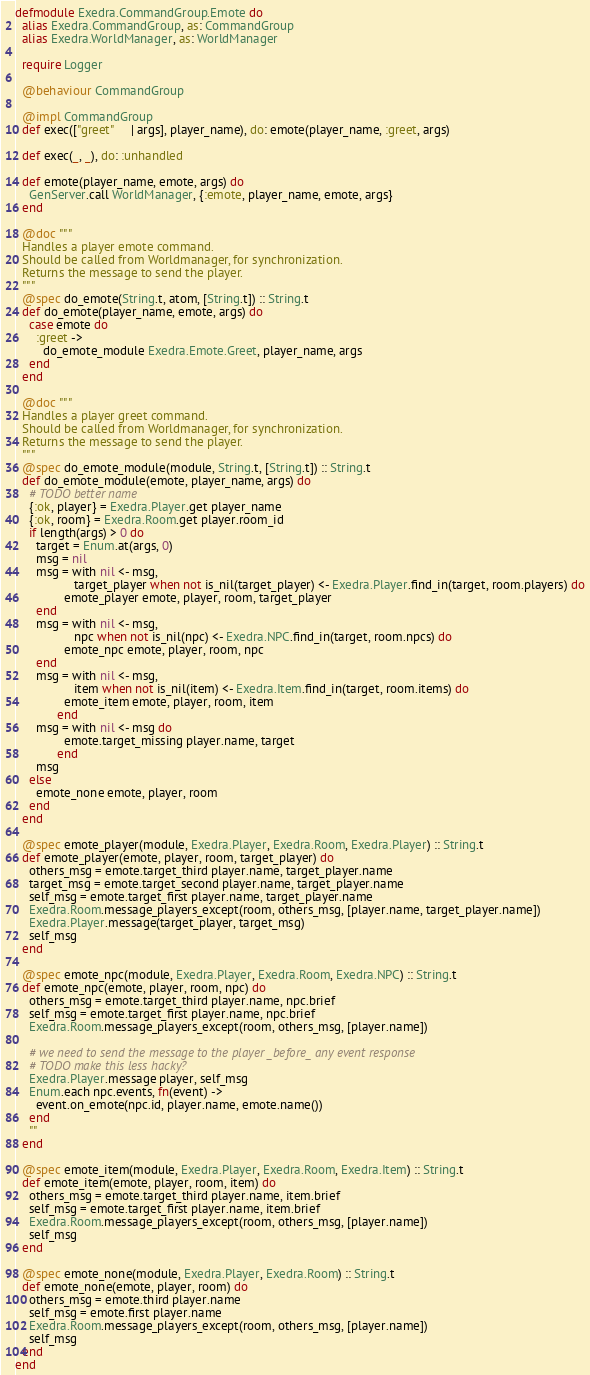Convert code to text. <code><loc_0><loc_0><loc_500><loc_500><_Elixir_>defmodule Exedra.CommandGroup.Emote do
  alias Exedra.CommandGroup, as: CommandGroup
  alias Exedra.WorldManager, as: WorldManager

  require Logger

  @behaviour CommandGroup

  @impl CommandGroup
  def exec(["greet"     | args], player_name), do: emote(player_name, :greet, args)

  def exec(_, _), do: :unhandled

  def emote(player_name, emote, args) do
    GenServer.call WorldManager, {:emote, player_name, emote, args}
  end

  @doc """
  Handles a player emote command.
  Should be called from Worldmanager, for synchronization.
  Returns the message to send the player.
  """
  @spec do_emote(String.t, atom, [String.t]) :: String.t
  def do_emote(player_name, emote, args) do
    case emote do
      :greet ->
        do_emote_module Exedra.Emote.Greet, player_name, args
    end
  end

  @doc """
  Handles a player greet command.
  Should be called from Worldmanager, for synchronization.
  Returns the message to send the player.
  """
  @spec do_emote_module(module, String.t, [String.t]) :: String.t
  def do_emote_module(emote, player_name, args) do
    # TODO better name
    {:ok, player} = Exedra.Player.get player_name
    {:ok, room} = Exedra.Room.get player.room_id
    if length(args) > 0 do
      target = Enum.at(args, 0)
      msg = nil
      msg = with nil <- msg,
                 target_player when not is_nil(target_player) <- Exedra.Player.find_in(target, room.players) do
              emote_player emote, player, room, target_player
      end
      msg = with nil <- msg,
                 npc when not is_nil(npc) <- Exedra.NPC.find_in(target, room.npcs) do
              emote_npc emote, player, room, npc
      end
      msg = with nil <- msg,
                 item when not is_nil(item) <- Exedra.Item.find_in(target, room.items) do
              emote_item emote, player, room, item
            end
      msg = with nil <- msg do
              emote.target_missing player.name, target
            end
      msg
    else
      emote_none emote, player, room
    end
  end

  @spec emote_player(module, Exedra.Player, Exedra.Room, Exedra.Player) :: String.t
  def emote_player(emote, player, room, target_player) do
    others_msg = emote.target_third player.name, target_player.name
    target_msg = emote.target_second player.name, target_player.name
    self_msg = emote.target_first player.name, target_player.name
    Exedra.Room.message_players_except(room, others_msg, [player.name, target_player.name])
    Exedra.Player.message(target_player, target_msg)
    self_msg
  end

  @spec emote_npc(module, Exedra.Player, Exedra.Room, Exedra.NPC) :: String.t
  def emote_npc(emote, player, room, npc) do
    others_msg = emote.target_third player.name, npc.brief
    self_msg = emote.target_first player.name, npc.brief
    Exedra.Room.message_players_except(room, others_msg, [player.name])

    # we need to send the message to the player _before_ any event response
    # TODO make this less hacky?
    Exedra.Player.message player, self_msg
    Enum.each npc.events, fn(event) ->
      event.on_emote(npc.id, player.name, emote.name())
    end
    ""
  end

  @spec emote_item(module, Exedra.Player, Exedra.Room, Exedra.Item) :: String.t
  def emote_item(emote, player, room, item) do
    others_msg = emote.target_third player.name, item.brief
    self_msg = emote.target_first player.name, item.brief
    Exedra.Room.message_players_except(room, others_msg, [player.name])
    self_msg
  end

  @spec emote_none(module, Exedra.Player, Exedra.Room) :: String.t
  def emote_none(emote, player, room) do
    others_msg = emote.third player.name
    self_msg = emote.first player.name
    Exedra.Room.message_players_except(room, others_msg, [player.name])
    self_msg
  end
end
</code> 